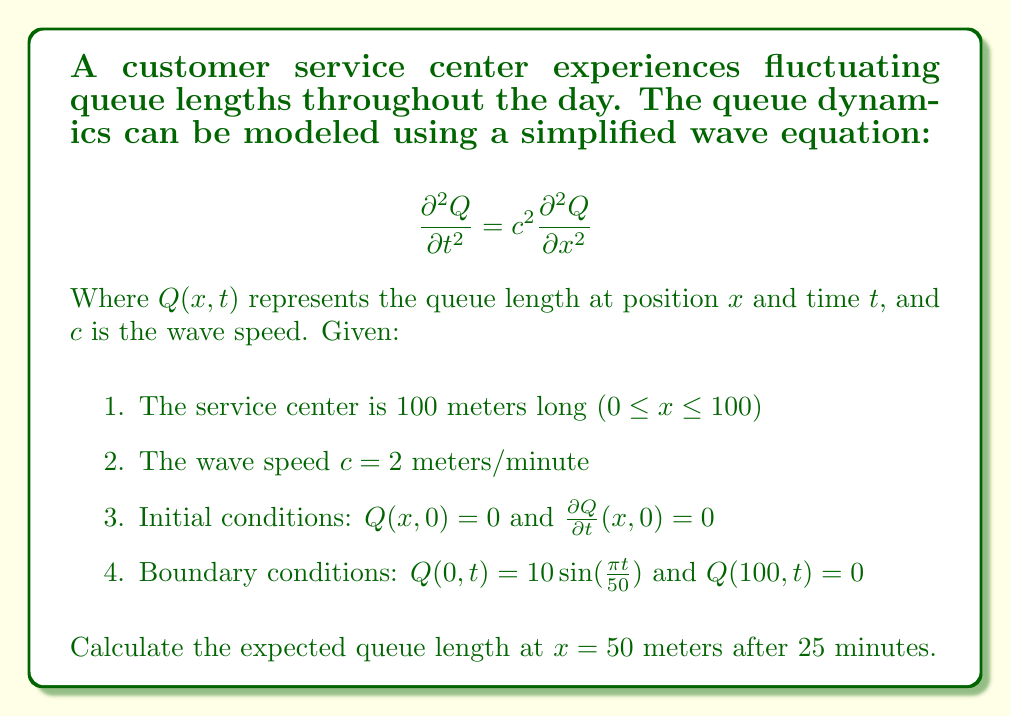Can you solve this math problem? To solve this problem, we need to use the method of separation of variables for the wave equation with the given initial and boundary conditions. Let's approach this step-by-step:

1) We assume a solution of the form $Q(x,t) = X(x)T(t)$.

2) Substituting this into the wave equation:

   $$X(x)T''(t) = c^2X''(x)T(t)$$

3) Separating variables:

   $$\frac{T''(t)}{c^2T(t)} = \frac{X''(x)}{X(x)} = -\lambda^2$$

4) This gives us two ODEs:
   
   $$X''(x) + \lambda^2X(x) = 0$$
   $$T''(t) + c^2\lambda^2T(t) = 0$$

5) The general solutions are:
   
   $$X(x) = A\sin(\lambda x) + B\cos(\lambda x)$$
   $$T(t) = C\sin(c\lambda t) + D\cos(c\lambda t)$$

6) Applying the boundary condition $Q(100,t) = 0$:

   $$X(100) = 0 \implies \lambda = \frac{n\pi}{100}, n = 1,2,3,...$$

7) The general solution is then:

   $$Q(x,t) = \sum_{n=1}^{\infty} [A_n\sin(\frac{n\pi x}{100}) + B_n\cos(\frac{n\pi x}{100})][C_n\sin(\frac{n\pi ct}{50}) + D_n\cos(\frac{n\pi ct}{50})]$$

8) Applying the initial conditions:

   $Q(x,0) = 0 \implies B_n = 0$ for all $n$
   $\frac{\partial Q}{\partial t}(x,0) = 0 \implies C_n = 0$ for all $n$

9) Our solution simplifies to:

   $$Q(x,t) = \sum_{n=1}^{\infty} A_n\sin(\frac{n\pi x}{100})\cos(\frac{n\pi ct}{50})$$

10) The remaining boundary condition $Q(0,t) = 10 \sin(\frac{\pi t}{50})$ implies that only the first term $(n=1)$ in our series is non-zero, and $A_1 = 10$.

11) Therefore, our final solution is:

    $$Q(x,t) = 10\sin(\frac{\pi x}{100})\cos(\frac{\pi ct}{50})$$

12) Substituting the given values $(x=50, t=25, c=2)$:

    $$Q(50,25) = 10\sin(\frac{\pi 50}{100})\cos(\frac{\pi 2 25}{50})$$
    $$= 10\sin(\frac{\pi}{2})\cos(\pi)$$
    $$= 10 \cdot 1 \cdot (-1) = -10$$

The negative value indicates that the queue is in the opposite direction of the positive x-axis at this point in time.
Answer: The expected queue length at $x = 50$ meters after 25 minutes is 10 people (in the opposite direction). 